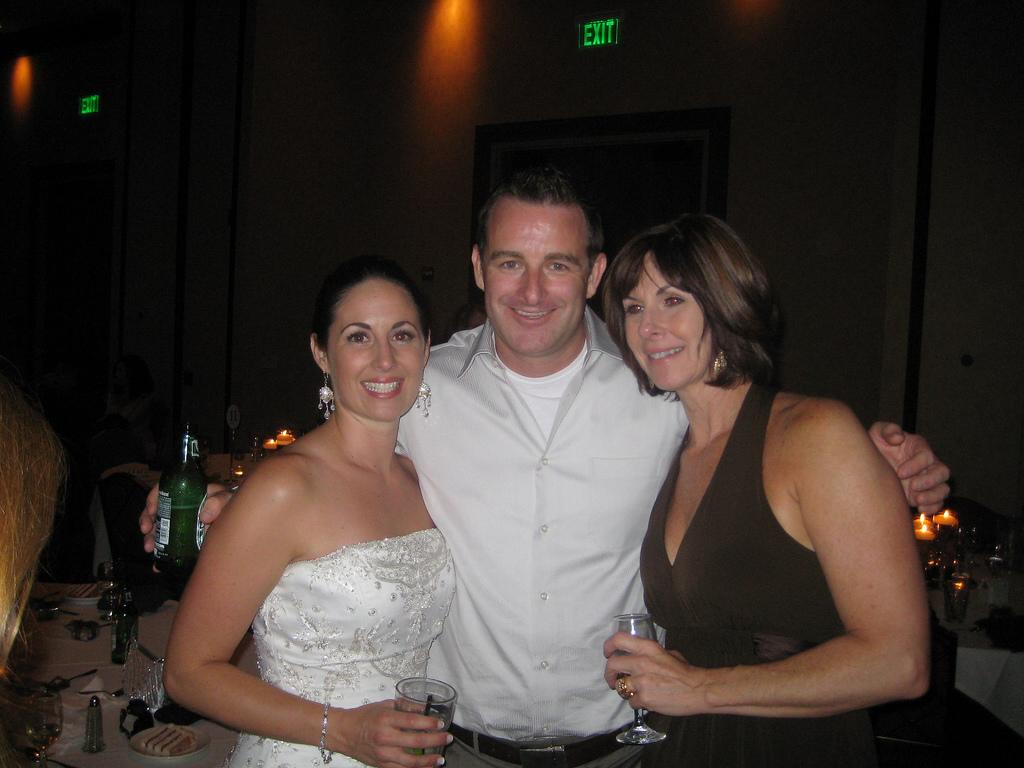How many people are in the image? There are two women and a man in the image. What expressions do the people in the image have? The women and the man are smiling. What is one of the women holding in the image? One of the women is holding a wine glass. What is the other woman holding in the image? The other woman is also holding a wine glass. What is the man holding in the image? The man is holding a glass bottle. What type of tax is being discussed by the people in the image? There is no indication in the image that the people are discussing any type of tax. What arithmetic problem is being solved by the rabbit in the image? There is no rabbit present in the image, and therefore no arithmetic problem being solved. 